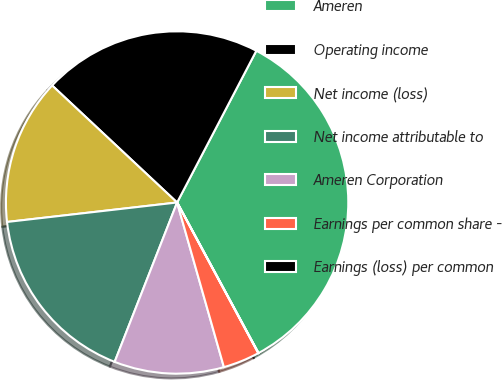Convert chart to OTSL. <chart><loc_0><loc_0><loc_500><loc_500><pie_chart><fcel>Ameren<fcel>Operating income<fcel>Net income (loss)<fcel>Net income attributable to<fcel>Ameren Corporation<fcel>Earnings per common share -<fcel>Earnings (loss) per common<nl><fcel>34.45%<fcel>20.68%<fcel>13.79%<fcel>17.24%<fcel>10.35%<fcel>3.46%<fcel>0.02%<nl></chart> 